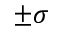<formula> <loc_0><loc_0><loc_500><loc_500>\pm \sigma</formula> 